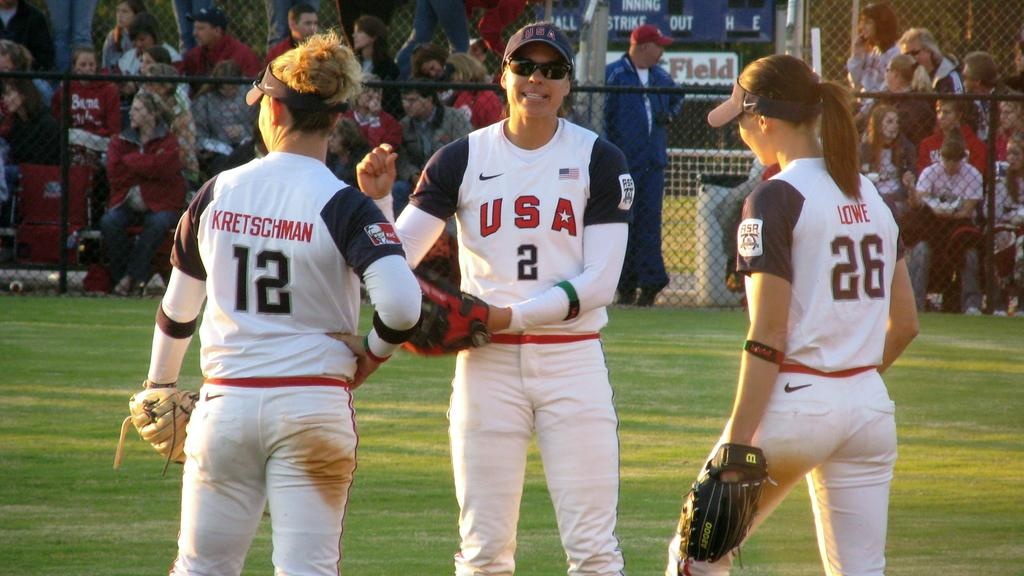<image>
Describe the image concisely. Players 12, 2, and 26 of the USA baseball team are all standing next to each other. 